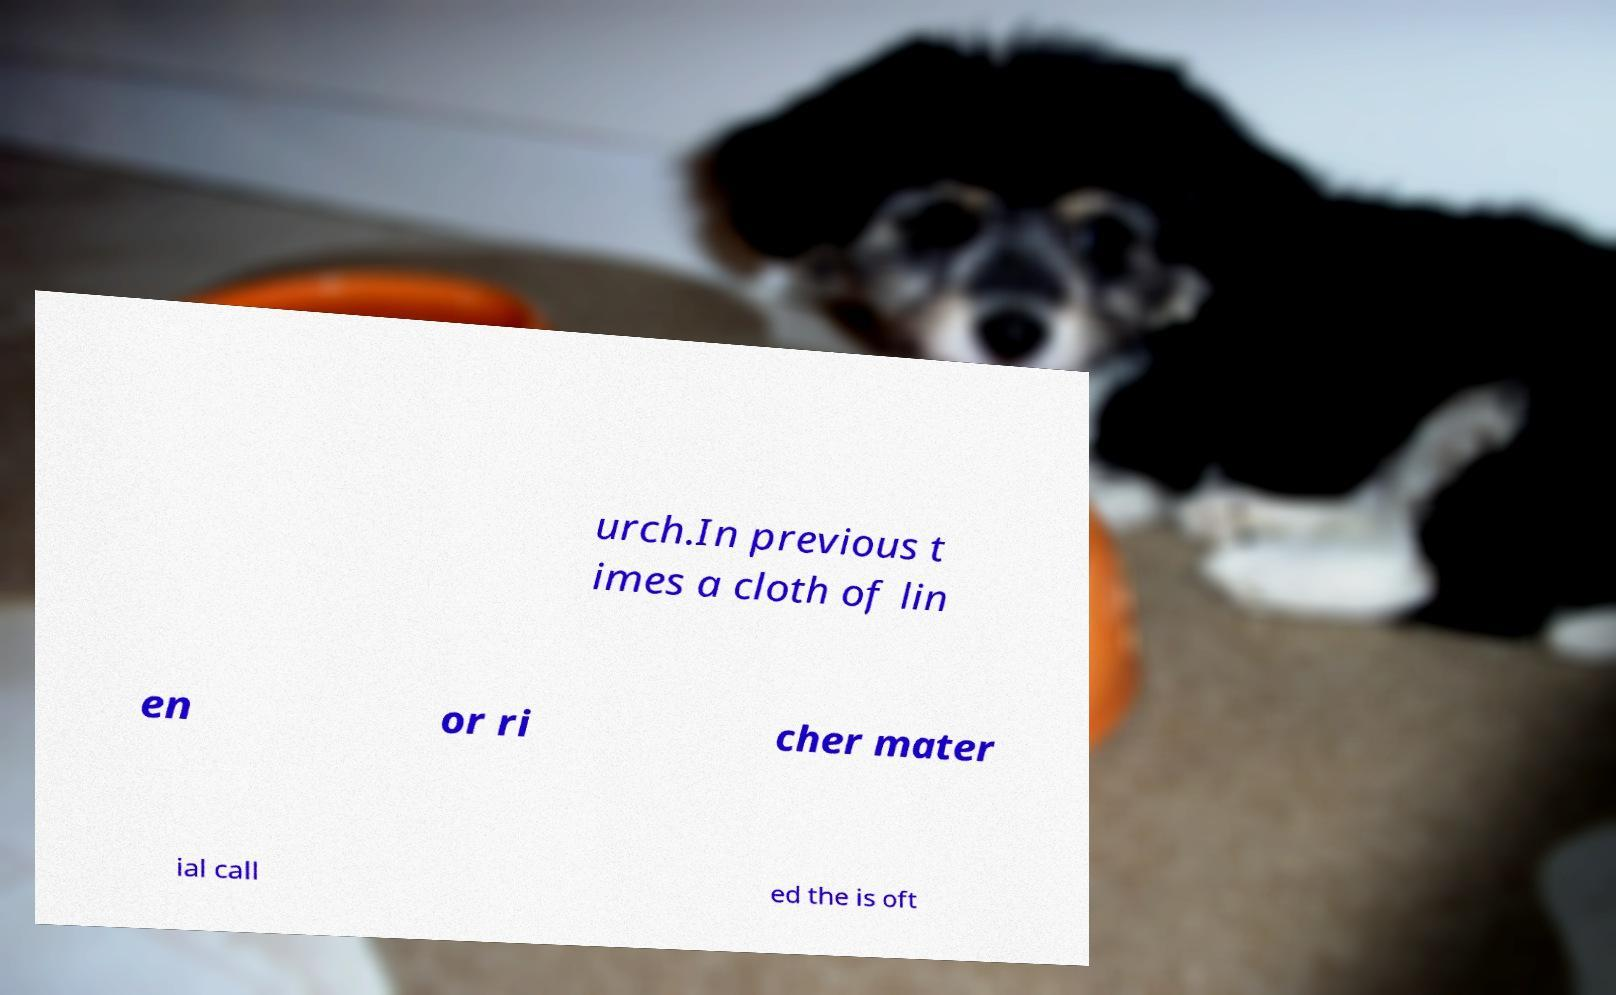I need the written content from this picture converted into text. Can you do that? urch.In previous t imes a cloth of lin en or ri cher mater ial call ed the is oft 